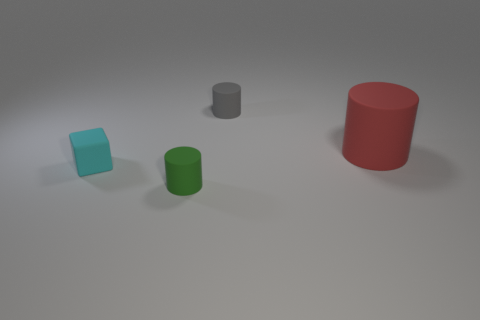What number of tiny things have the same material as the small green cylinder?
Your response must be concise. 2. Are there fewer tiny gray rubber things than large shiny spheres?
Your answer should be very brief. No. There is a matte cylinder that is left of the small gray rubber cylinder; is its color the same as the cube?
Give a very brief answer. No. There is a small cylinder that is right of the rubber cylinder to the left of the gray rubber object; what number of big cylinders are on the right side of it?
Provide a short and direct response. 1. There is a small gray rubber cylinder; how many rubber objects are in front of it?
Make the answer very short. 3. What color is the other large matte thing that is the same shape as the green rubber object?
Give a very brief answer. Red. There is a thing that is both in front of the red cylinder and right of the small matte cube; what material is it made of?
Your answer should be compact. Rubber. Does the object that is to the right of the gray rubber thing have the same size as the gray thing?
Your answer should be compact. No. What is the material of the red thing?
Your response must be concise. Rubber. There is a matte cylinder that is behind the large rubber thing; what color is it?
Your answer should be compact. Gray. 